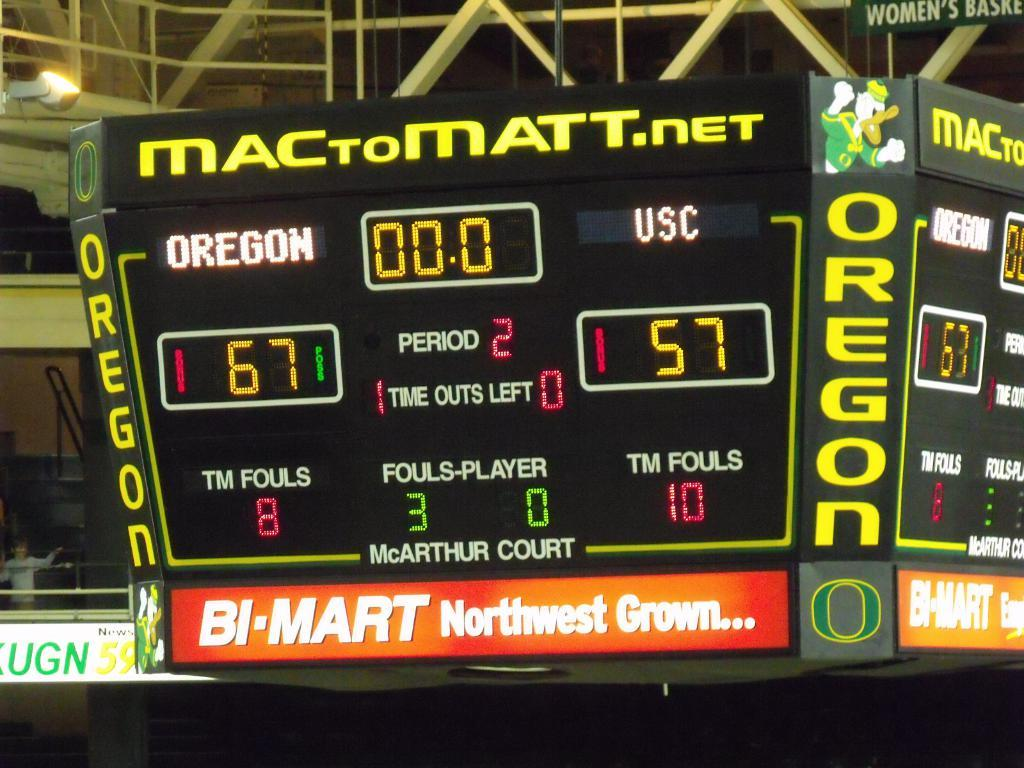<image>
Render a clear and concise summary of the photo. A scoreboard reads, "MACTOMATT.net" with the teams "OREGON" and "USC" at "McARTHUR COURT." 